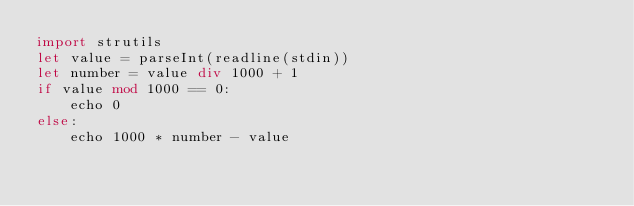Convert code to text. <code><loc_0><loc_0><loc_500><loc_500><_Nim_>import strutils
let value = parseInt(readline(stdin))
let number = value div 1000 + 1
if value mod 1000 == 0:
    echo 0
else:
    echo 1000 * number - value</code> 